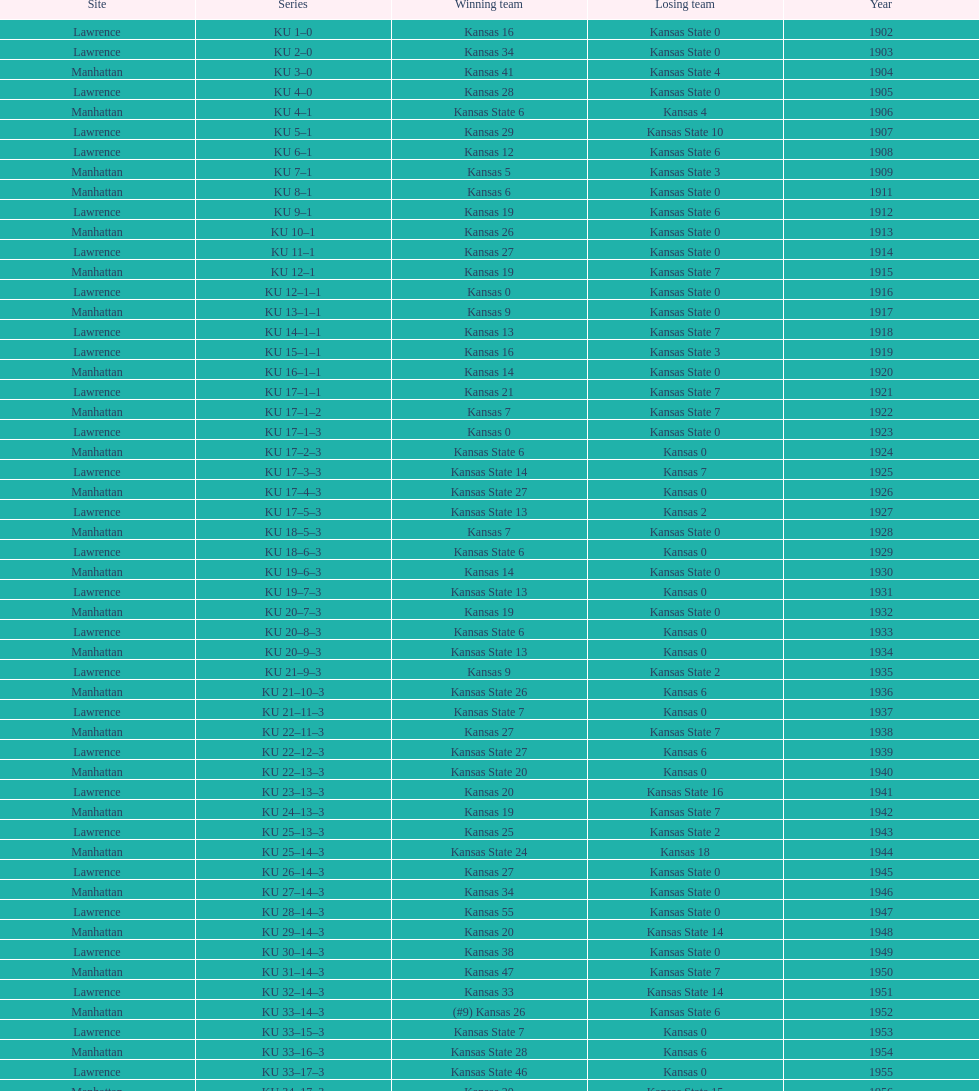When was the first game that kansas state won by double digits? 1926. 